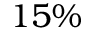<formula> <loc_0><loc_0><loc_500><loc_500>1 5 \%</formula> 